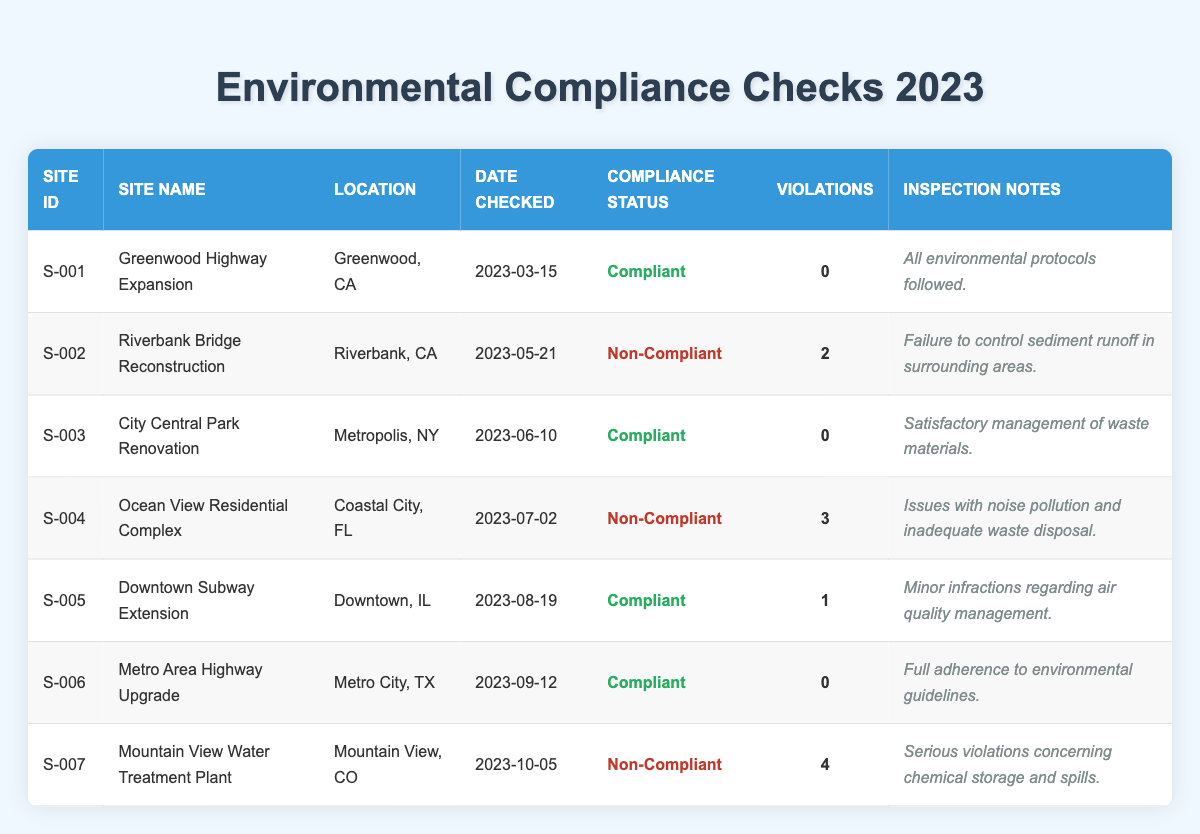What is the compliance status of the Downtown Subway Extension site? Referring to the table, under the column "Site Name," find "Downtown Subway Extension." The corresponding "Compliance Status" column shows "Compliant."
Answer: Compliant How many violations were reported for the Ocean View Residential Complex? In the table, locate the row for "Ocean View Residential Complex." The "Violations" column indicates a value of 3.
Answer: 3 Which site had the highest number of violations? Scan the "Violations" column in the table. The "Mountain View Water Treatment Plant" has 4 violations, more than any other site listed, indicating it's the site with the most violations.
Answer: Mountain View Water Treatment Plant Is the Riverbank Bridge Reconstruction compliant with environmental protocols? Check the compliance status for "Riverbank Bridge Reconstruction" in the table. The "Compliance Status" is listed as "Non-Compliant," answering the question negatively.
Answer: No What is the total number of violations across all sites? To calculate the total violations, add the number of violations reported for each site: 0 + 2 + 0 + 3 + 1 + 0 + 4 = 10.
Answer: 10 Which sites were compliant during their last inspection? Look through the "Compliance Status" column, identifying sites marked as "Compliant." These are "Greenwood Highway Expansion," "City Central Park Renovation," "Downtown Subway Extension," and "Metro Area Highway Upgrade."
Answer: 4 sites What percentage of sites inspected in 2023 were compliant? There are 7 sites in total, and out of these, 4 are compliant. To find the percentage, calculate (4/7) * 100 = 57.14%. Round this to two decimal places to get a final percentage.
Answer: 57.14% How many sites were inspected after July 1, 2023? Review the "Date Checked" column for sites inspected from July onward: Ocean View (July 2), Downtown Subway (August 19), Metro Area (September 12), and Mountain View (October 5). This gives a total of 4 sites.
Answer: 4 sites What is the inspection note for the Metro Area Highway Upgrade? Find the row corresponding to "Metro Area Highway Upgrade" and read the information in the "Inspection Notes" column which states: "Full adherence to environmental guidelines."
Answer: Full adherence to environmental guidelines Which site had a violation related to chemical storage? Reviewing the "Inspection Notes" for each site, the "Mountain View Water Treatment Plant" specifically mentions "Serious violations concerning chemical storage and spills."
Answer: Mountain View Water Treatment Plant 